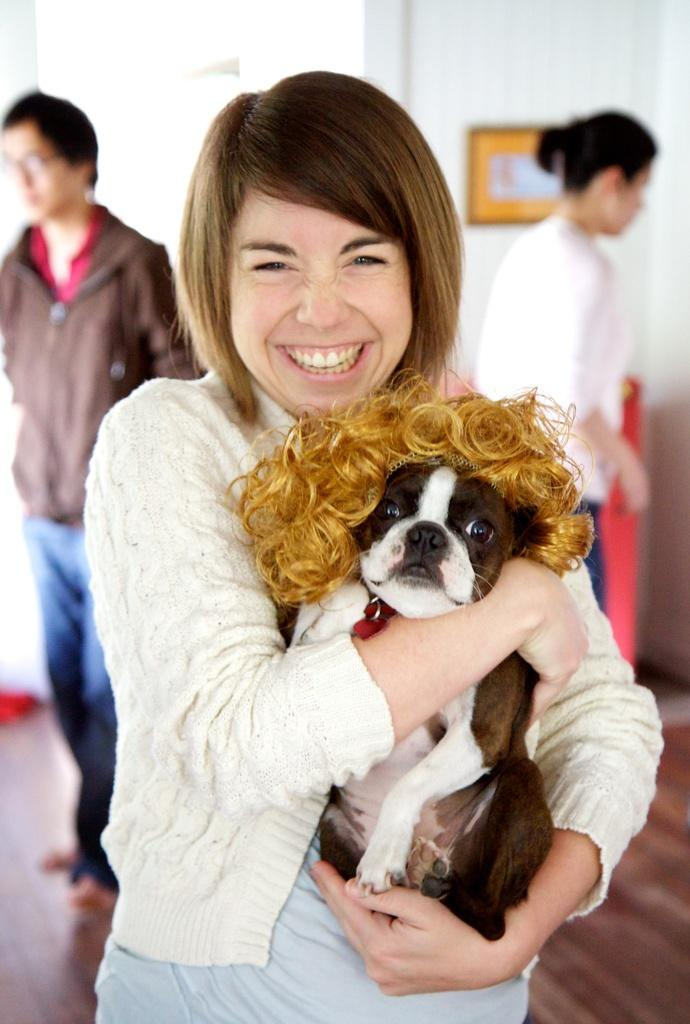What is the person in the image holding? The person is holding a dog in the image. How many people are visible in the image? There are three people visible in the image. Can you describe the position of the other two people? The other two people are standing behind the person holding the dog. What type of chess pieces can be seen on the ground in the image? There is no mention of chess pieces or a game of chess in the image. 